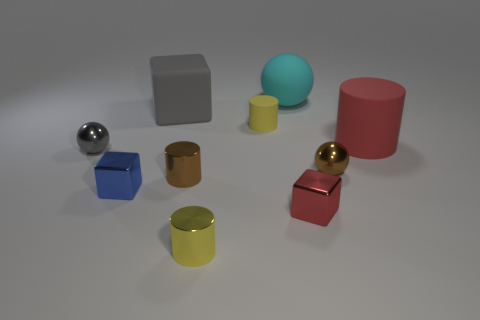Subtract all balls. How many objects are left? 7 Subtract all spheres. Subtract all red rubber cylinders. How many objects are left? 6 Add 6 yellow objects. How many yellow objects are left? 8 Add 3 big rubber cylinders. How many big rubber cylinders exist? 4 Subtract 0 yellow blocks. How many objects are left? 10 